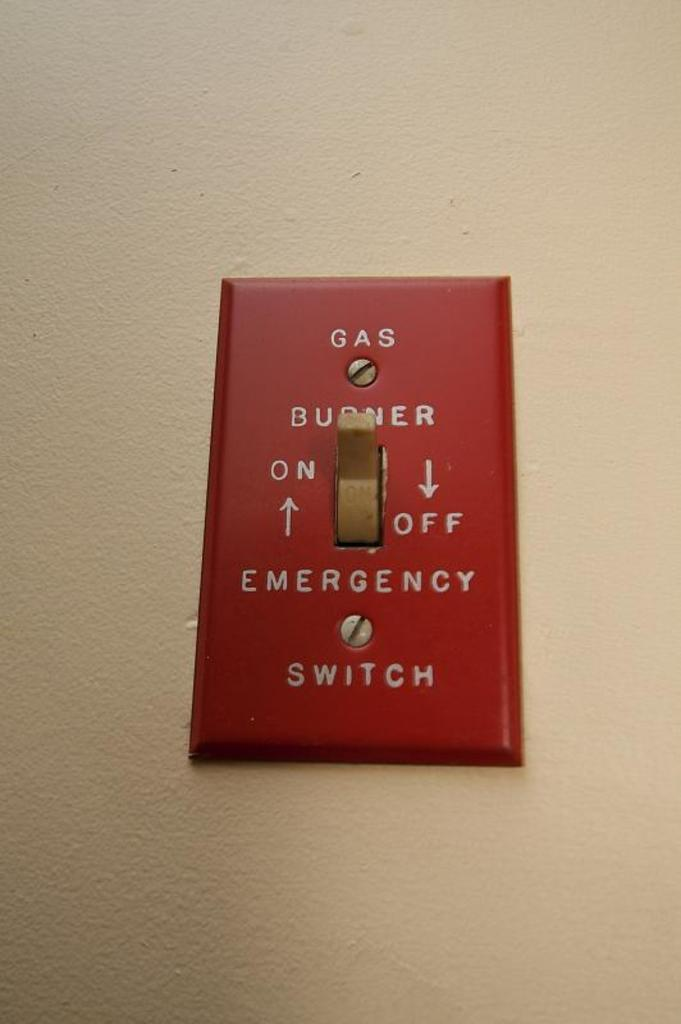<image>
Describe the image concisely. A switch on the wall is labeled Gas Burner. 